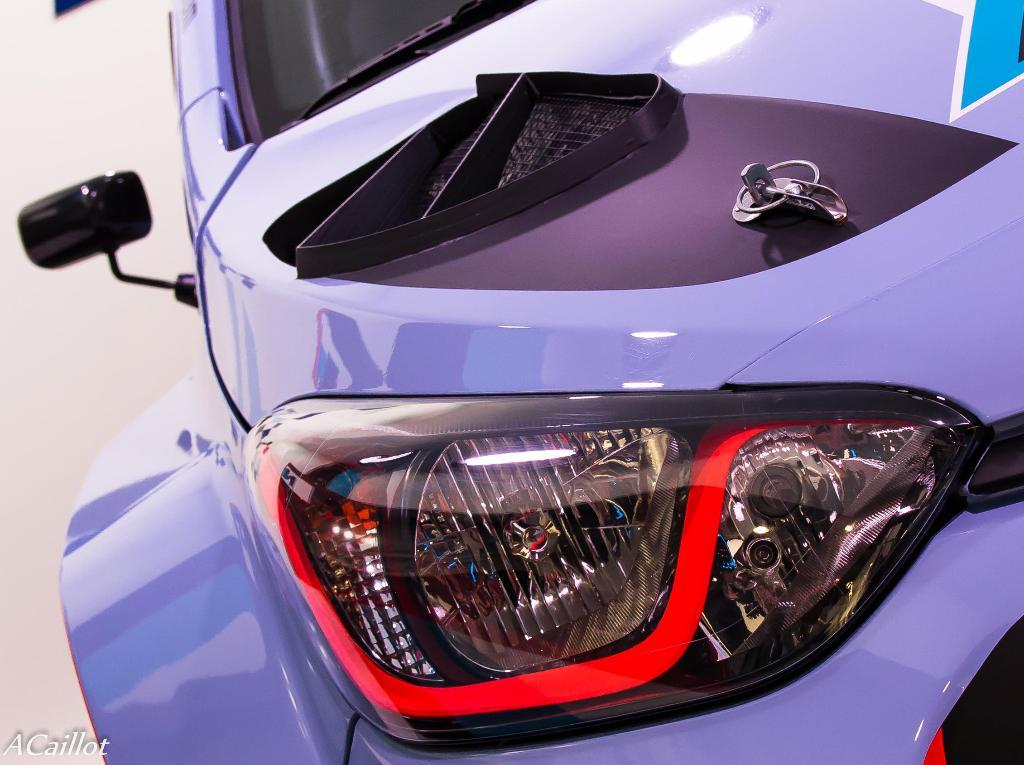What is the main subject in the image? There is a vehicle in the image. What type of peace symbol can be seen in the image? There is no peace symbol present in the image; it only features a vehicle. What shape is the fact in the image? There is no fact present in the image, as it is a visual representation of a vehicle. 